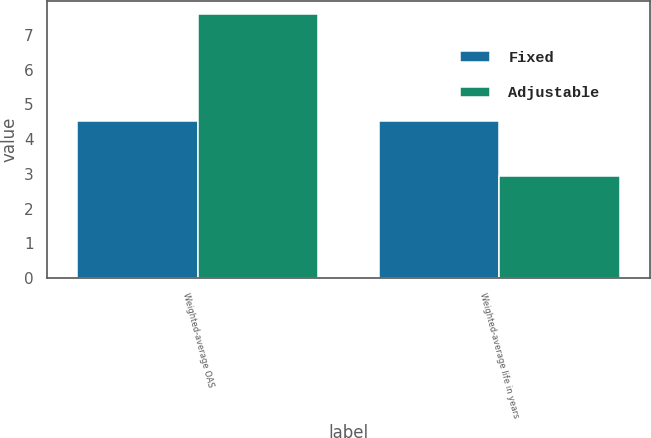<chart> <loc_0><loc_0><loc_500><loc_500><stacked_bar_chart><ecel><fcel>Weighted-average OAS<fcel>Weighted-average life in years<nl><fcel>Fixed<fcel>4.52<fcel>4.53<nl><fcel>Adjustable<fcel>7.61<fcel>2.95<nl></chart> 